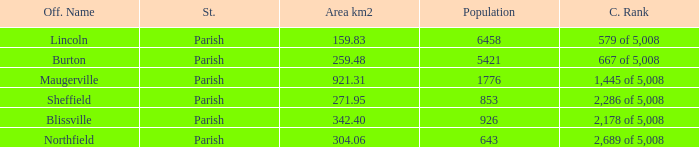What is the status(es) of the place with an area of 304.06 km2? Parish. 